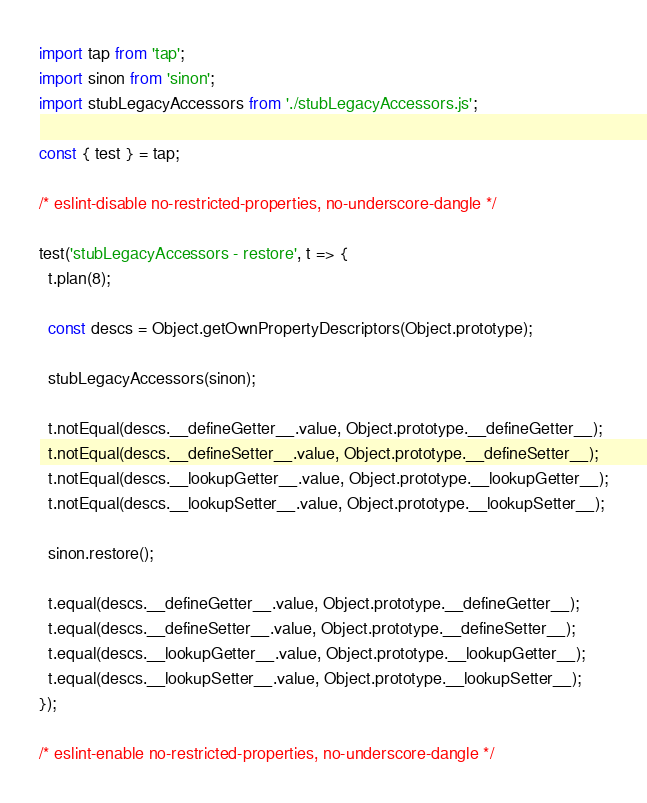<code> <loc_0><loc_0><loc_500><loc_500><_JavaScript_>import tap from 'tap';
import sinon from 'sinon';
import stubLegacyAccessors from './stubLegacyAccessors.js';

const { test } = tap;

/* eslint-disable no-restricted-properties, no-underscore-dangle */

test('stubLegacyAccessors - restore', t => {
  t.plan(8);

  const descs = Object.getOwnPropertyDescriptors(Object.prototype);

  stubLegacyAccessors(sinon);

  t.notEqual(descs.__defineGetter__.value, Object.prototype.__defineGetter__);
  t.notEqual(descs.__defineSetter__.value, Object.prototype.__defineSetter__);
  t.notEqual(descs.__lookupGetter__.value, Object.prototype.__lookupGetter__);
  t.notEqual(descs.__lookupSetter__.value, Object.prototype.__lookupSetter__);

  sinon.restore();

  t.equal(descs.__defineGetter__.value, Object.prototype.__defineGetter__);
  t.equal(descs.__defineSetter__.value, Object.prototype.__defineSetter__);
  t.equal(descs.__lookupGetter__.value, Object.prototype.__lookupGetter__);
  t.equal(descs.__lookupSetter__.value, Object.prototype.__lookupSetter__);
});

/* eslint-enable no-restricted-properties, no-underscore-dangle */
</code> 